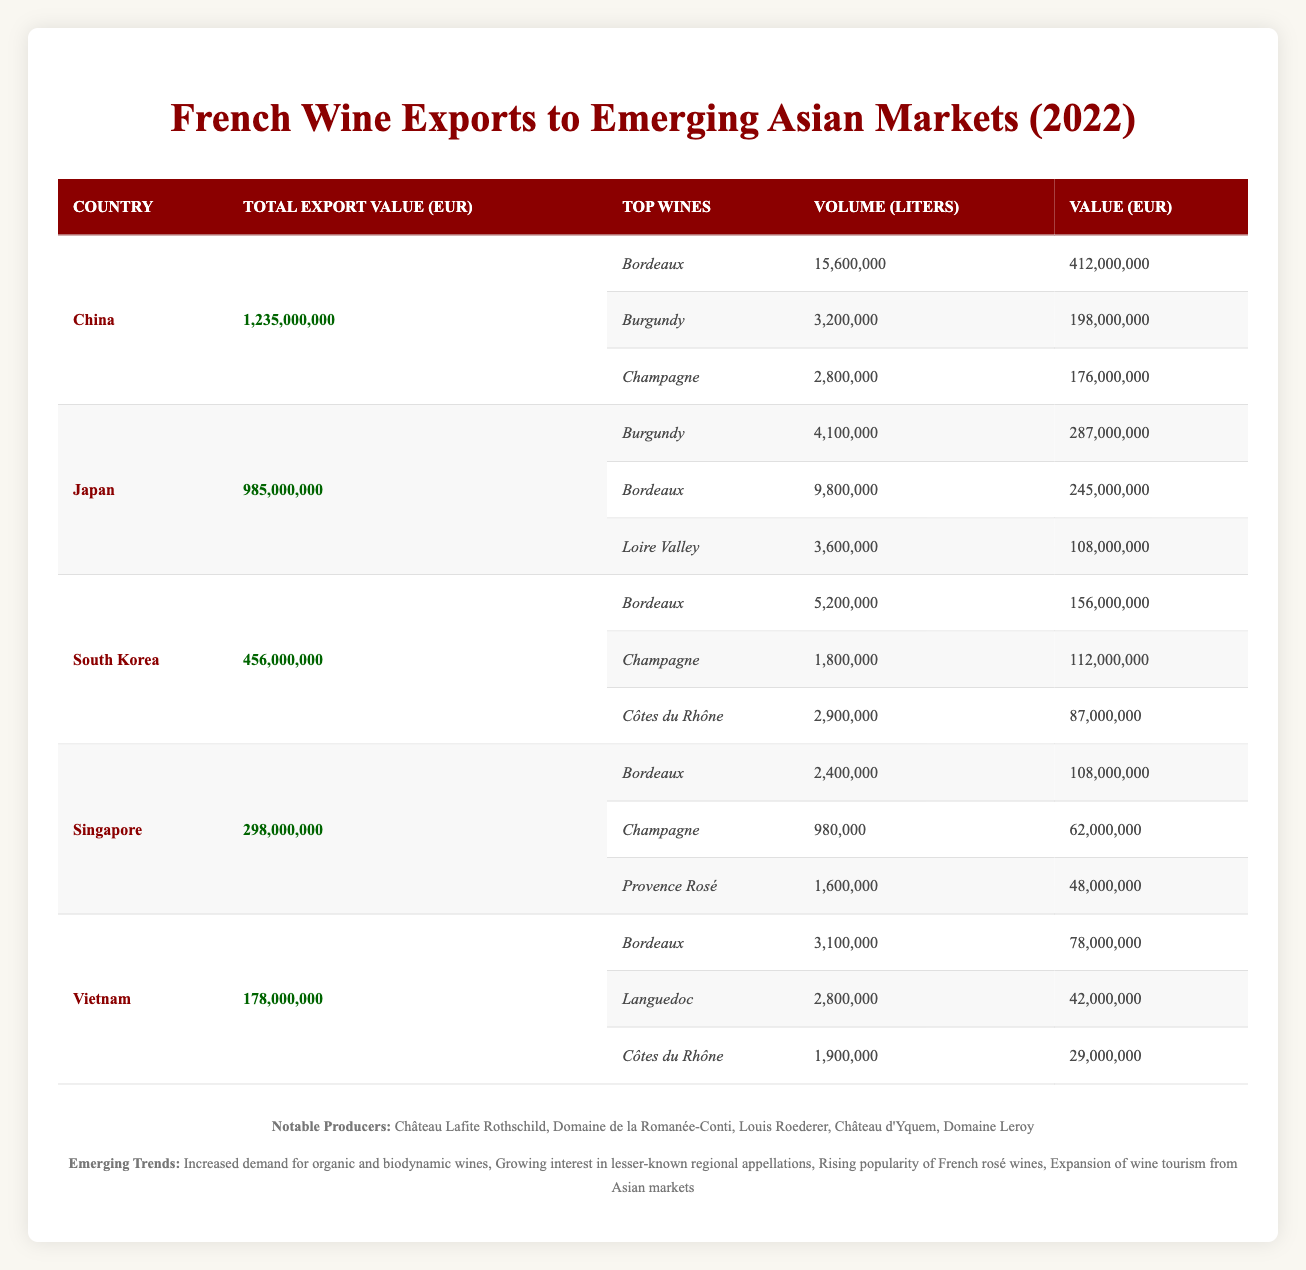What is the total export value of French wines to China in 2022? The table shows that the total export value for China is clearly indicated in the column labeled "Total Export Value (EUR)", which states 1,235,000,000.
Answer: 1,235,000,000 Which country had the highest total export value for French wines in 2022? By comparing the total export values across all countries listed in the table, China (1,235,000,000) surpasses the others like Japan (985,000,000), South Korea (456,000,000), Singapore (298,000,000), and Vietnam (178,000,000).
Answer: China What is the combined export value of Bordeaux wines sold to Japan and South Korea? First, find the value of Bordeaux exported to Japan (245,000,000) and South Korea (156,000,000). Then sum these values: 245,000,000 + 156,000,000 = 401,000,000.
Answer: 401,000,000 Is it true that Champagne was one of the top three wines exported to Singapore? Check the "Top Wines" listed for Singapore and find the wines exported. The table lists Champagne among the top three wines exported to Singapore. Therefore, the statement is true.
Answer: Yes What is the volume of Burgundy wine exported to Japan? The table specifically shows the volume of Burgundy wine exported to Japan, which is 4,100,000 liters in the respective row.
Answer: 4,100,000 liters Which two countries had the highest value of Bordeaux wines exported? From the table, the values for Bordeaux exports are: China (412,000,000) and Japan (245,000,000). By comparing these values, China has the highest followed by Japan.
Answer: China, Japan How many liters of Bordeaux wine were exported to Vietnam? The table states that the volume of Bordeaux wine exported to Vietnam is 3,100,000 liters. This information can be found in the relevant row for Vietnam.
Answer: 3,100,000 liters What is the average total export value for all five countries listed? To calculate the average, sum the total export values: 1,235,000,000 (China) + 985,000,000 (Japan) + 456,000,000 (South Korea) + 298,000,000 (Singapore) + 178,000,000 (Vietnam) = 3,152,000,000. Then divide by 5 (the number of countries): 3,152,000,000 / 5 = 630,400,000.
Answer: 630,400,000 Which wine had the lowest export value in Vietnam and what was that value? In Vietnam's row, the wines listed with their values show Côtes du Rhône with a value of 29,000,000. This is the lowest among the wines listed for Vietnam.
Answer: Côtes du Rhône, 29,000,000 